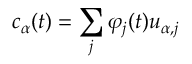<formula> <loc_0><loc_0><loc_500><loc_500>c _ { \alpha } ( t ) = \sum _ { j } \varphi _ { j } ( t ) u _ { \alpha , j }</formula> 